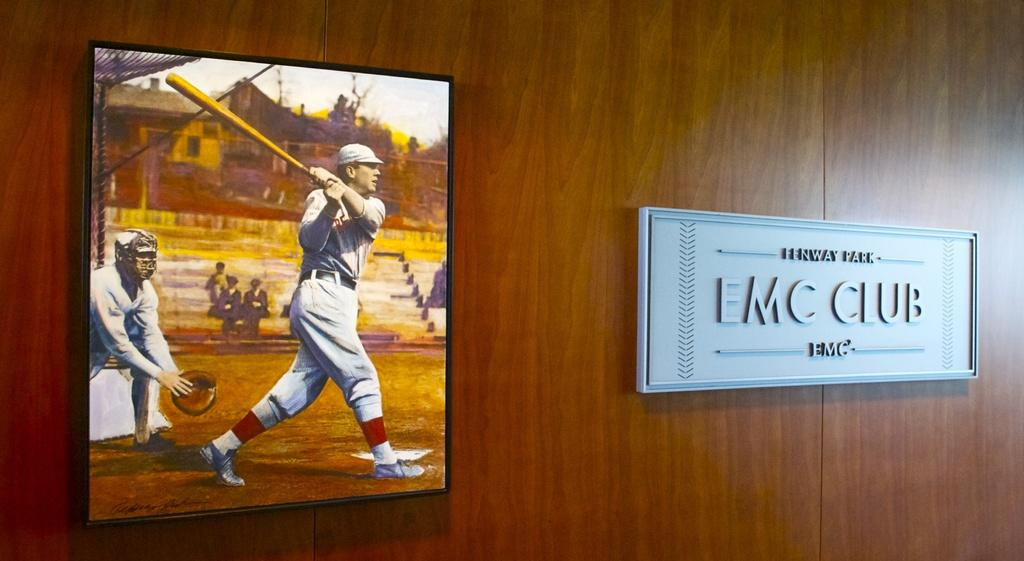<image>
Render a clear and concise summary of the photo. A painting of a baseball player and catcher hangs next to a sign saying EMC club in Febway Park. 